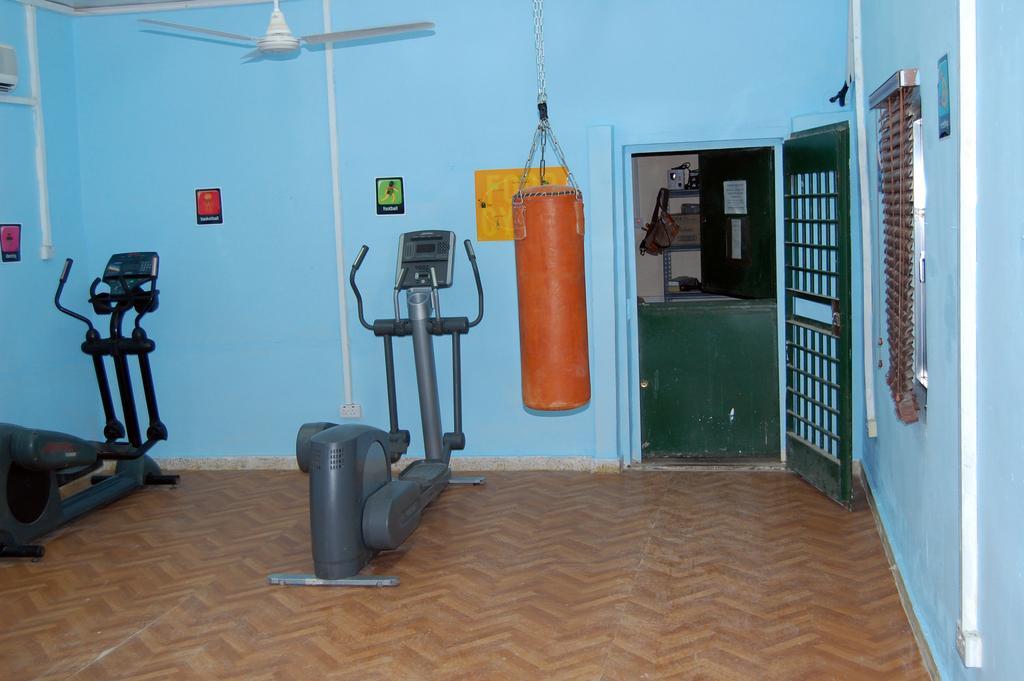In one or two sentences, can you explain what this image depicts? In this image, I can see two elliptical trainers on the floor. On the right side of the image, I can see the blinds. I can see a punching bag and a ceiling fan and there are posters attached to the walls. In the background, there is a room with objects and a door. 